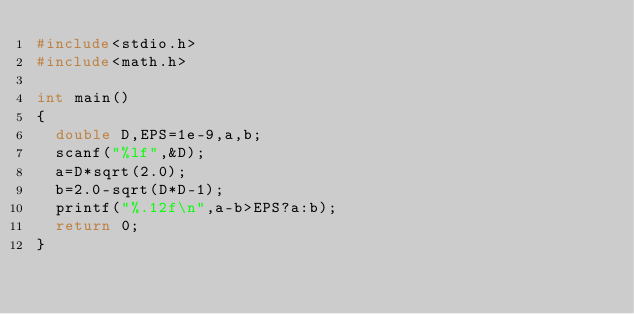<code> <loc_0><loc_0><loc_500><loc_500><_C_>#include<stdio.h>
#include<math.h>

int main()
{
	double D,EPS=1e-9,a,b;
	scanf("%lf",&D);
	a=D*sqrt(2.0);
	b=2.0-sqrt(D*D-1);
	printf("%.12f\n",a-b>EPS?a:b);
	return 0;
}</code> 